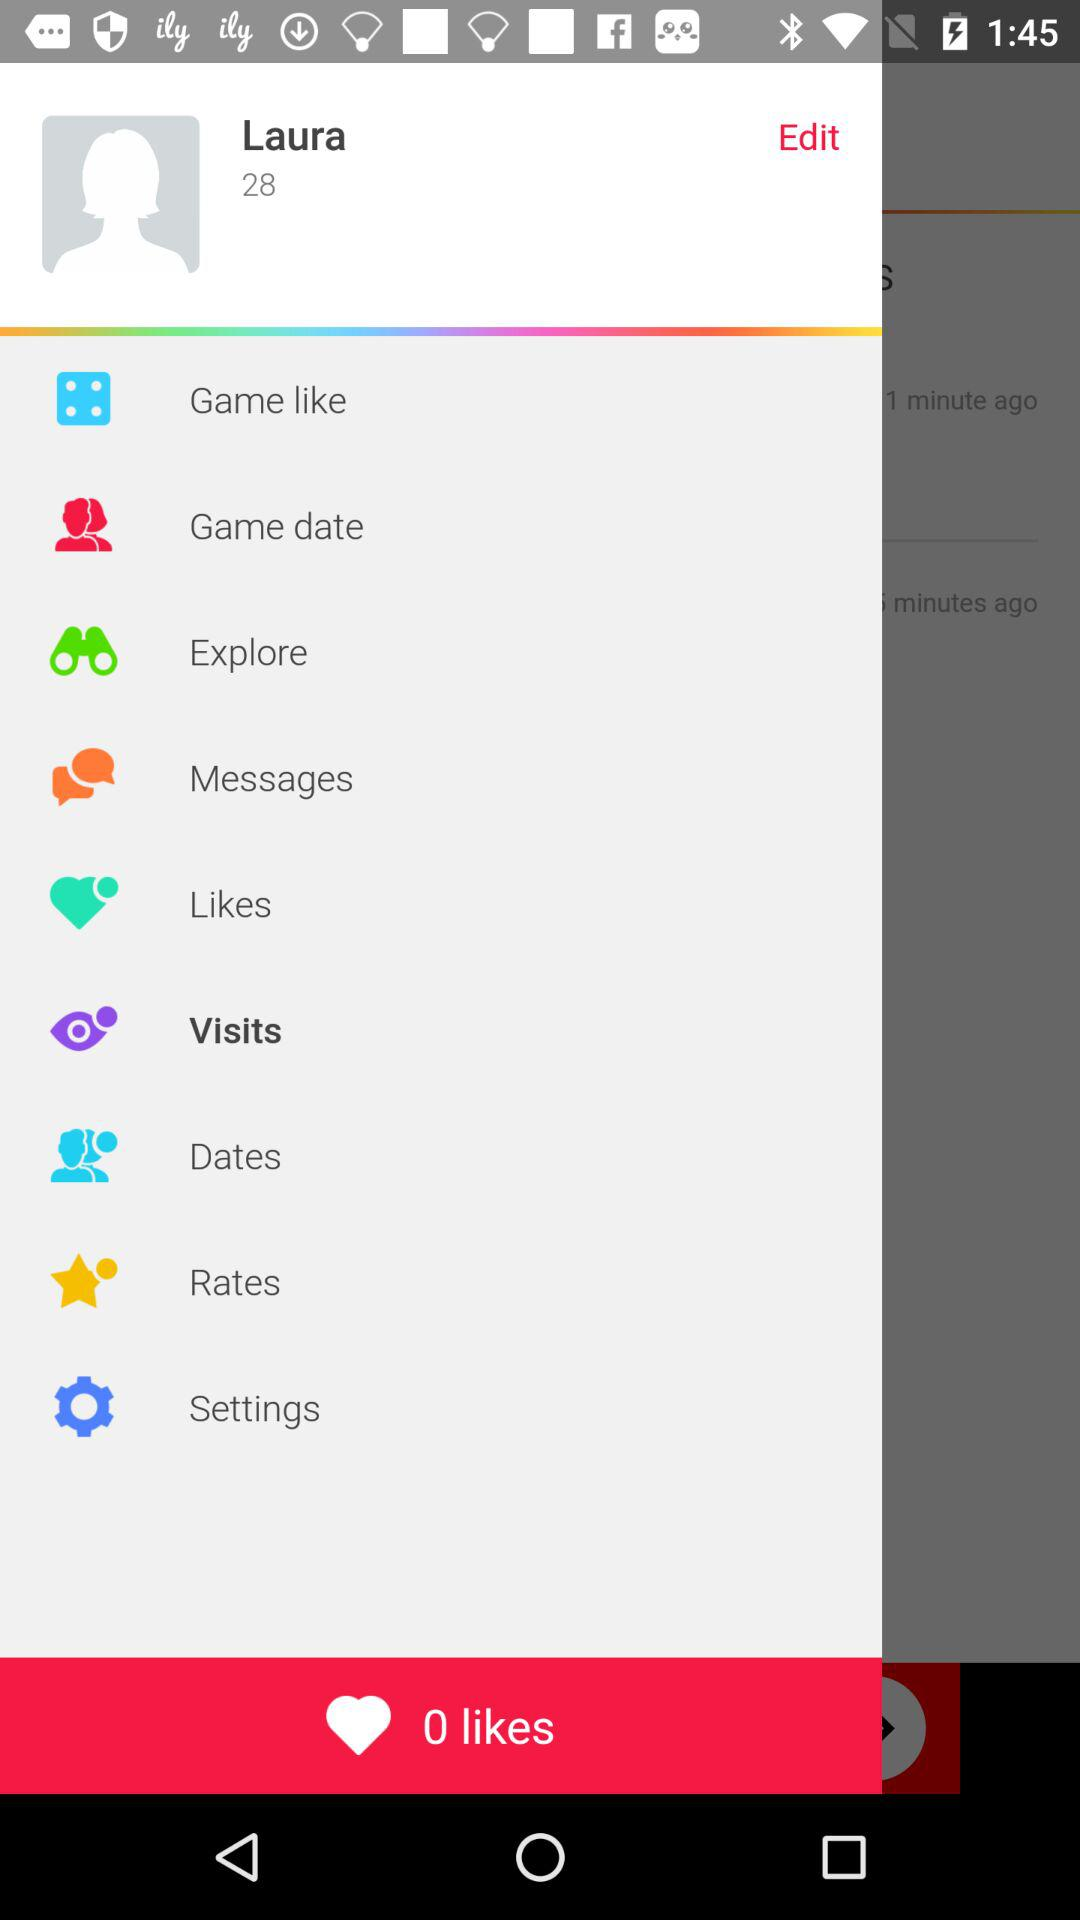How many unread messages are there?
When the provided information is insufficient, respond with <no answer>. <no answer> 